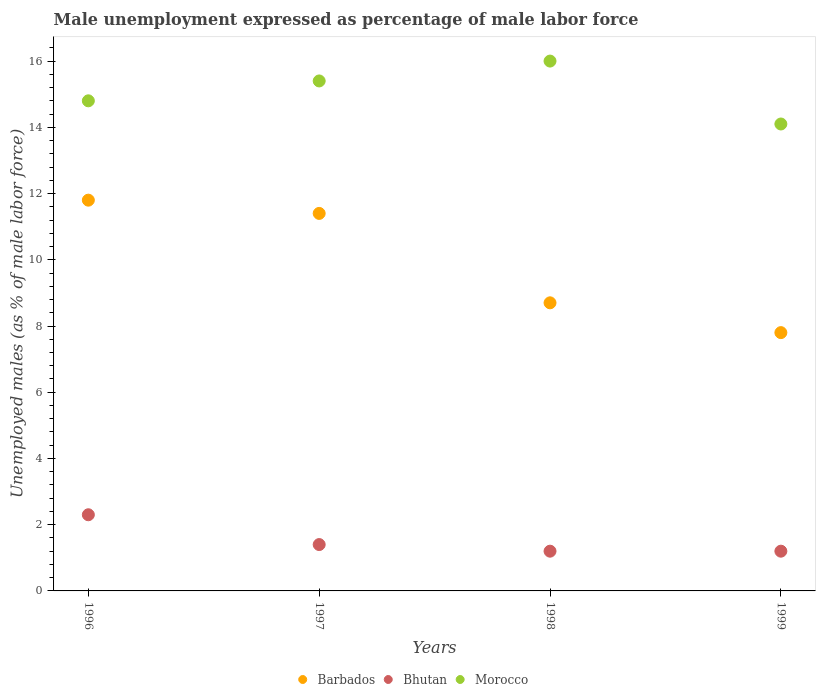How many different coloured dotlines are there?
Provide a short and direct response. 3. Is the number of dotlines equal to the number of legend labels?
Ensure brevity in your answer.  Yes. What is the unemployment in males in in Bhutan in 1998?
Offer a terse response. 1.2. Across all years, what is the maximum unemployment in males in in Bhutan?
Provide a succinct answer. 2.3. Across all years, what is the minimum unemployment in males in in Bhutan?
Your answer should be very brief. 1.2. In which year was the unemployment in males in in Barbados minimum?
Give a very brief answer. 1999. What is the total unemployment in males in in Barbados in the graph?
Your answer should be compact. 39.7. What is the difference between the unemployment in males in in Barbados in 1996 and that in 1999?
Your answer should be very brief. 4. What is the difference between the unemployment in males in in Barbados in 1999 and the unemployment in males in in Morocco in 1996?
Offer a very short reply. -7. What is the average unemployment in males in in Bhutan per year?
Make the answer very short. 1.53. In the year 1996, what is the difference between the unemployment in males in in Barbados and unemployment in males in in Bhutan?
Offer a terse response. 9.5. In how many years, is the unemployment in males in in Morocco greater than 8.8 %?
Your response must be concise. 4. What is the ratio of the unemployment in males in in Barbados in 1997 to that in 1998?
Ensure brevity in your answer.  1.31. Is the difference between the unemployment in males in in Barbados in 1996 and 1998 greater than the difference between the unemployment in males in in Bhutan in 1996 and 1998?
Offer a very short reply. Yes. What is the difference between the highest and the second highest unemployment in males in in Bhutan?
Make the answer very short. 0.9. What is the difference between the highest and the lowest unemployment in males in in Morocco?
Provide a short and direct response. 1.9. In how many years, is the unemployment in males in in Bhutan greater than the average unemployment in males in in Bhutan taken over all years?
Offer a very short reply. 1. Is the sum of the unemployment in males in in Barbados in 1996 and 1998 greater than the maximum unemployment in males in in Morocco across all years?
Ensure brevity in your answer.  Yes. Is it the case that in every year, the sum of the unemployment in males in in Morocco and unemployment in males in in Barbados  is greater than the unemployment in males in in Bhutan?
Offer a terse response. Yes. Does the unemployment in males in in Morocco monotonically increase over the years?
Provide a short and direct response. No. Is the unemployment in males in in Morocco strictly greater than the unemployment in males in in Barbados over the years?
Offer a terse response. Yes. Is the unemployment in males in in Bhutan strictly less than the unemployment in males in in Morocco over the years?
Offer a very short reply. Yes. How many years are there in the graph?
Make the answer very short. 4. Are the values on the major ticks of Y-axis written in scientific E-notation?
Keep it short and to the point. No. How many legend labels are there?
Your answer should be very brief. 3. What is the title of the graph?
Your response must be concise. Male unemployment expressed as percentage of male labor force. Does "Kuwait" appear as one of the legend labels in the graph?
Offer a terse response. No. What is the label or title of the Y-axis?
Your answer should be compact. Unemployed males (as % of male labor force). What is the Unemployed males (as % of male labor force) of Barbados in 1996?
Keep it short and to the point. 11.8. What is the Unemployed males (as % of male labor force) in Bhutan in 1996?
Ensure brevity in your answer.  2.3. What is the Unemployed males (as % of male labor force) in Morocco in 1996?
Offer a terse response. 14.8. What is the Unemployed males (as % of male labor force) in Barbados in 1997?
Provide a succinct answer. 11.4. What is the Unemployed males (as % of male labor force) in Bhutan in 1997?
Give a very brief answer. 1.4. What is the Unemployed males (as % of male labor force) of Morocco in 1997?
Keep it short and to the point. 15.4. What is the Unemployed males (as % of male labor force) in Barbados in 1998?
Offer a very short reply. 8.7. What is the Unemployed males (as % of male labor force) in Bhutan in 1998?
Offer a very short reply. 1.2. What is the Unemployed males (as % of male labor force) in Morocco in 1998?
Offer a very short reply. 16. What is the Unemployed males (as % of male labor force) in Barbados in 1999?
Provide a short and direct response. 7.8. What is the Unemployed males (as % of male labor force) in Bhutan in 1999?
Provide a succinct answer. 1.2. What is the Unemployed males (as % of male labor force) of Morocco in 1999?
Ensure brevity in your answer.  14.1. Across all years, what is the maximum Unemployed males (as % of male labor force) of Barbados?
Provide a succinct answer. 11.8. Across all years, what is the maximum Unemployed males (as % of male labor force) of Bhutan?
Provide a short and direct response. 2.3. Across all years, what is the minimum Unemployed males (as % of male labor force) in Barbados?
Offer a very short reply. 7.8. Across all years, what is the minimum Unemployed males (as % of male labor force) in Bhutan?
Give a very brief answer. 1.2. Across all years, what is the minimum Unemployed males (as % of male labor force) in Morocco?
Your response must be concise. 14.1. What is the total Unemployed males (as % of male labor force) of Barbados in the graph?
Give a very brief answer. 39.7. What is the total Unemployed males (as % of male labor force) of Bhutan in the graph?
Offer a terse response. 6.1. What is the total Unemployed males (as % of male labor force) of Morocco in the graph?
Offer a very short reply. 60.3. What is the difference between the Unemployed males (as % of male labor force) in Morocco in 1996 and that in 1997?
Offer a very short reply. -0.6. What is the difference between the Unemployed males (as % of male labor force) of Morocco in 1996 and that in 1998?
Provide a short and direct response. -1.2. What is the difference between the Unemployed males (as % of male labor force) of Bhutan in 1996 and that in 1999?
Make the answer very short. 1.1. What is the difference between the Unemployed males (as % of male labor force) in Morocco in 1996 and that in 1999?
Your response must be concise. 0.7. What is the difference between the Unemployed males (as % of male labor force) of Bhutan in 1997 and that in 1998?
Make the answer very short. 0.2. What is the difference between the Unemployed males (as % of male labor force) of Morocco in 1997 and that in 1998?
Offer a terse response. -0.6. What is the difference between the Unemployed males (as % of male labor force) of Barbados in 1997 and that in 1999?
Your response must be concise. 3.6. What is the difference between the Unemployed males (as % of male labor force) in Barbados in 1998 and that in 1999?
Provide a succinct answer. 0.9. What is the difference between the Unemployed males (as % of male labor force) in Morocco in 1998 and that in 1999?
Keep it short and to the point. 1.9. What is the difference between the Unemployed males (as % of male labor force) in Barbados in 1996 and the Unemployed males (as % of male labor force) in Bhutan in 1997?
Offer a very short reply. 10.4. What is the difference between the Unemployed males (as % of male labor force) in Barbados in 1996 and the Unemployed males (as % of male labor force) in Morocco in 1997?
Keep it short and to the point. -3.6. What is the difference between the Unemployed males (as % of male labor force) in Bhutan in 1996 and the Unemployed males (as % of male labor force) in Morocco in 1997?
Your answer should be compact. -13.1. What is the difference between the Unemployed males (as % of male labor force) of Barbados in 1996 and the Unemployed males (as % of male labor force) of Bhutan in 1998?
Give a very brief answer. 10.6. What is the difference between the Unemployed males (as % of male labor force) in Barbados in 1996 and the Unemployed males (as % of male labor force) in Morocco in 1998?
Your response must be concise. -4.2. What is the difference between the Unemployed males (as % of male labor force) in Bhutan in 1996 and the Unemployed males (as % of male labor force) in Morocco in 1998?
Make the answer very short. -13.7. What is the difference between the Unemployed males (as % of male labor force) in Barbados in 1996 and the Unemployed males (as % of male labor force) in Morocco in 1999?
Give a very brief answer. -2.3. What is the difference between the Unemployed males (as % of male labor force) in Bhutan in 1996 and the Unemployed males (as % of male labor force) in Morocco in 1999?
Give a very brief answer. -11.8. What is the difference between the Unemployed males (as % of male labor force) in Barbados in 1997 and the Unemployed males (as % of male labor force) in Bhutan in 1998?
Provide a short and direct response. 10.2. What is the difference between the Unemployed males (as % of male labor force) in Barbados in 1997 and the Unemployed males (as % of male labor force) in Morocco in 1998?
Offer a very short reply. -4.6. What is the difference between the Unemployed males (as % of male labor force) of Bhutan in 1997 and the Unemployed males (as % of male labor force) of Morocco in 1998?
Provide a succinct answer. -14.6. What is the difference between the Unemployed males (as % of male labor force) of Bhutan in 1997 and the Unemployed males (as % of male labor force) of Morocco in 1999?
Give a very brief answer. -12.7. What is the difference between the Unemployed males (as % of male labor force) of Barbados in 1998 and the Unemployed males (as % of male labor force) of Bhutan in 1999?
Provide a succinct answer. 7.5. What is the difference between the Unemployed males (as % of male labor force) in Bhutan in 1998 and the Unemployed males (as % of male labor force) in Morocco in 1999?
Your answer should be very brief. -12.9. What is the average Unemployed males (as % of male labor force) of Barbados per year?
Ensure brevity in your answer.  9.93. What is the average Unemployed males (as % of male labor force) of Bhutan per year?
Your answer should be compact. 1.52. What is the average Unemployed males (as % of male labor force) in Morocco per year?
Offer a terse response. 15.07. In the year 1996, what is the difference between the Unemployed males (as % of male labor force) in Barbados and Unemployed males (as % of male labor force) in Bhutan?
Provide a short and direct response. 9.5. In the year 1996, what is the difference between the Unemployed males (as % of male labor force) in Barbados and Unemployed males (as % of male labor force) in Morocco?
Your response must be concise. -3. In the year 1997, what is the difference between the Unemployed males (as % of male labor force) in Barbados and Unemployed males (as % of male labor force) in Morocco?
Offer a very short reply. -4. In the year 1998, what is the difference between the Unemployed males (as % of male labor force) in Bhutan and Unemployed males (as % of male labor force) in Morocco?
Offer a very short reply. -14.8. In the year 1999, what is the difference between the Unemployed males (as % of male labor force) in Barbados and Unemployed males (as % of male labor force) in Morocco?
Provide a short and direct response. -6.3. In the year 1999, what is the difference between the Unemployed males (as % of male labor force) of Bhutan and Unemployed males (as % of male labor force) of Morocco?
Your response must be concise. -12.9. What is the ratio of the Unemployed males (as % of male labor force) in Barbados in 1996 to that in 1997?
Ensure brevity in your answer.  1.04. What is the ratio of the Unemployed males (as % of male labor force) in Bhutan in 1996 to that in 1997?
Provide a short and direct response. 1.64. What is the ratio of the Unemployed males (as % of male labor force) of Barbados in 1996 to that in 1998?
Provide a succinct answer. 1.36. What is the ratio of the Unemployed males (as % of male labor force) of Bhutan in 1996 to that in 1998?
Offer a terse response. 1.92. What is the ratio of the Unemployed males (as % of male labor force) of Morocco in 1996 to that in 1998?
Give a very brief answer. 0.93. What is the ratio of the Unemployed males (as % of male labor force) in Barbados in 1996 to that in 1999?
Your response must be concise. 1.51. What is the ratio of the Unemployed males (as % of male labor force) in Bhutan in 1996 to that in 1999?
Your answer should be compact. 1.92. What is the ratio of the Unemployed males (as % of male labor force) in Morocco in 1996 to that in 1999?
Keep it short and to the point. 1.05. What is the ratio of the Unemployed males (as % of male labor force) in Barbados in 1997 to that in 1998?
Give a very brief answer. 1.31. What is the ratio of the Unemployed males (as % of male labor force) of Bhutan in 1997 to that in 1998?
Your answer should be compact. 1.17. What is the ratio of the Unemployed males (as % of male labor force) of Morocco in 1997 to that in 1998?
Provide a succinct answer. 0.96. What is the ratio of the Unemployed males (as % of male labor force) in Barbados in 1997 to that in 1999?
Your answer should be very brief. 1.46. What is the ratio of the Unemployed males (as % of male labor force) in Morocco in 1997 to that in 1999?
Make the answer very short. 1.09. What is the ratio of the Unemployed males (as % of male labor force) of Barbados in 1998 to that in 1999?
Make the answer very short. 1.12. What is the ratio of the Unemployed males (as % of male labor force) in Morocco in 1998 to that in 1999?
Keep it short and to the point. 1.13. What is the difference between the highest and the second highest Unemployed males (as % of male labor force) of Barbados?
Offer a terse response. 0.4. What is the difference between the highest and the second highest Unemployed males (as % of male labor force) in Morocco?
Provide a short and direct response. 0.6. What is the difference between the highest and the lowest Unemployed males (as % of male labor force) of Barbados?
Offer a very short reply. 4. What is the difference between the highest and the lowest Unemployed males (as % of male labor force) in Bhutan?
Offer a very short reply. 1.1. 